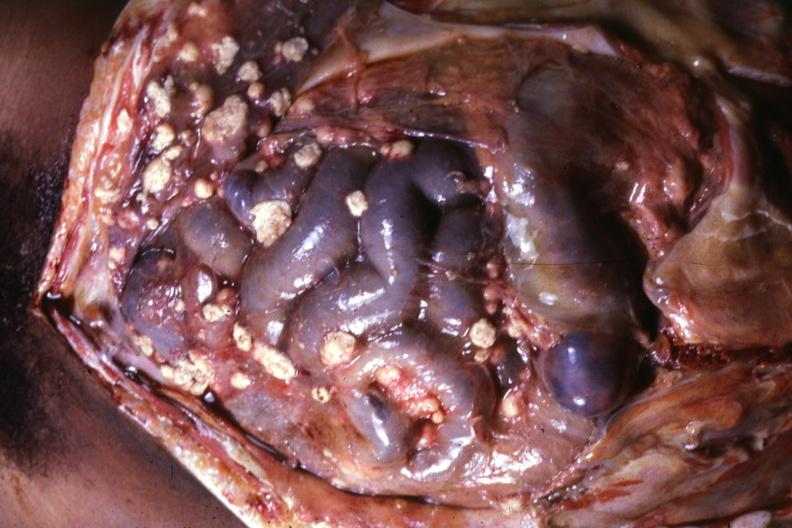what does this image show?
Answer the question using a single word or phrase. Opened abdominal cavity with atypically large lesions looking more like metastatic carcinoma 